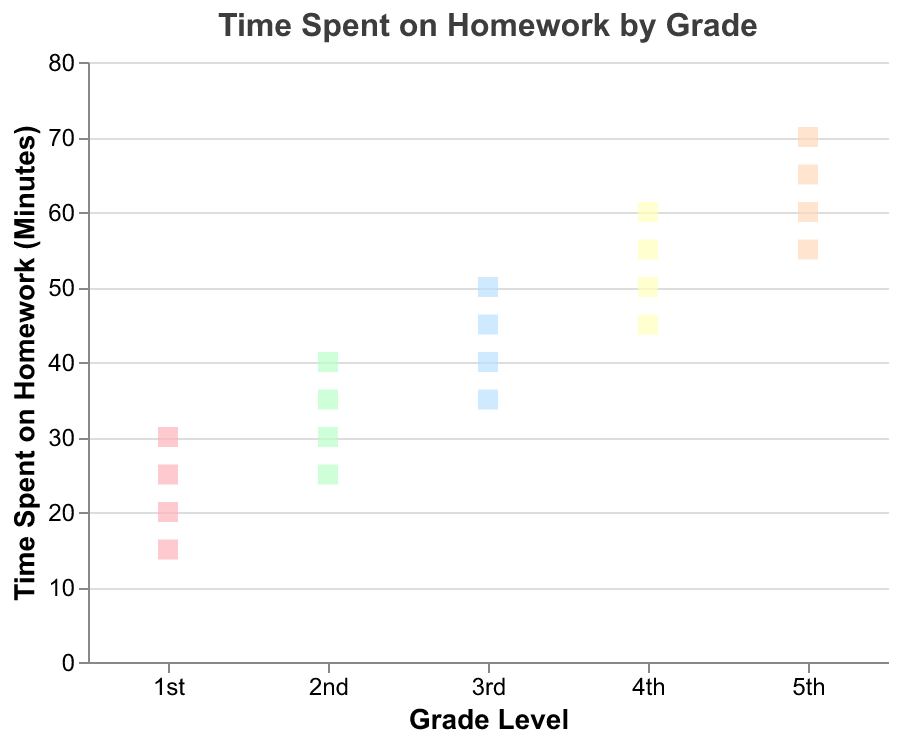What's the title of the figure? The title of the figure is typically placed at the top and is usually written in larger, bold font. Here, the title is "Time Spent on Homework by Grade".
Answer: Time Spent on Homework by Grade On which axis is the Grade Level shown? In the strip plot, the Grade Level is displayed on the horizontal axis, also known as the x-axis.
Answer: The horizontal axis What colors represent the different grades? Each grade is represented by a different color. For instance, the colors might range from shades like light red, light green, light blue, light yellow, and light orange.
Answer: Varied light colors such as light red, green, blue, yellow, and orange What is the range of time spent on homework for 3rd graders? Locate the data points for the 3rd grade on the x-axis and observe the range of the y-axis values these points cover. The time for 3rd graders ranges from 35 to 50 minutes.
Answer: 35 to 50 minutes How many data points are there for 2nd graders? Count the number of data points aligned vertically above the '2nd' label on the x-axis. There are 4 data points.
Answer: 4 Which grade has the highest recorded time spent on homework? Identify the highest data point on the y-axis and observe its corresponding grade on the x-axis. The highest data point is at 70 minutes, corresponding to the 5th grade.
Answer: 5th grade What is the median time spent on homework by 5th graders? Arrange the data points for 5th grade in ascending order: 55, 60, 65, 70. The median is the average of the two middle values (60 and 65), which is (60 + 65) / 2 = 62.5 minutes.
Answer: 62.5 minutes Is there a grade that has a wider variability in homework time than others? Compare the range of values (from minimum to maximum) for each grade. The 5th grade ranges from 55 to 70 minutes, which is a 15-minute span, indicating a wider variability compared to other grades.
Answer: Yes, it's the 5th grade How does the average time spent on homework change from 1st grade to 5th grade? Calculate the average for each grade by summing the data points and dividing by the number of points. 
1st grade: (15+20+25+30)/4 = 22.5 minutes
2nd grade: (25+30+35+40)/4 = 32.5 minutes
3rd grade: (35+40+45+50)/4 = 42.5 minutes
4th grade: (45+50+55+60)/4 = 52.5 minutes
5th grade: (55+60+65+70)/4 = 62.5 minutes
The average increases as the grade level increases.
Answer: It increases Which grade shows the smallest range of time spent on homework? Determine the range (difference between max and min values) for each grade. The smallest range is for 1st grade, which is 30 - 15 = 15 minutes.
Answer: 1st grade 